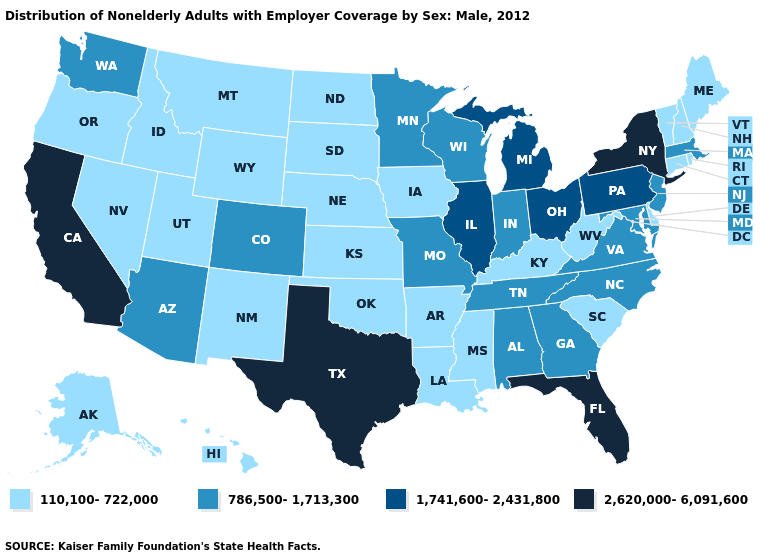Is the legend a continuous bar?
Write a very short answer. No. Among the states that border South Carolina , which have the lowest value?
Keep it brief. Georgia, North Carolina. What is the value of Kansas?
Quick response, please. 110,100-722,000. Which states have the highest value in the USA?
Write a very short answer. California, Florida, New York, Texas. What is the lowest value in the USA?
Be succinct. 110,100-722,000. What is the highest value in the USA?
Keep it brief. 2,620,000-6,091,600. What is the value of Virginia?
Be succinct. 786,500-1,713,300. How many symbols are there in the legend?
Write a very short answer. 4. Does South Carolina have a lower value than Arizona?
Write a very short answer. Yes. What is the value of Arkansas?
Concise answer only. 110,100-722,000. Which states hav the highest value in the Northeast?
Be succinct. New York. Is the legend a continuous bar?
Give a very brief answer. No. What is the lowest value in states that border Ohio?
Short answer required. 110,100-722,000. 